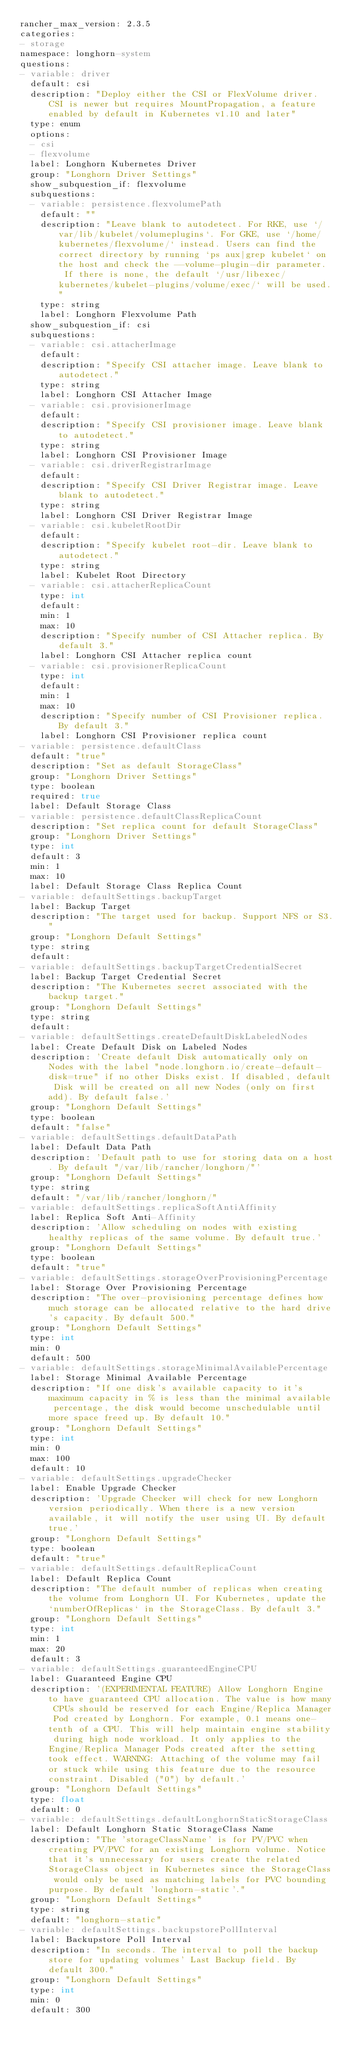<code> <loc_0><loc_0><loc_500><loc_500><_YAML_>rancher_max_version: 2.3.5
categories:
- storage
namespace: longhorn-system
questions:
- variable: driver
  default: csi
  description: "Deploy either the CSI or FlexVolume driver. CSI is newer but requires MountPropagation, a feature enabled by default in Kubernetes v1.10 and later"
  type: enum
  options:
  - csi
  - flexvolume
  label: Longhorn Kubernetes Driver
  group: "Longhorn Driver Settings"
  show_subquestion_if: flexvolume
  subquestions:
  - variable: persistence.flexvolumePath
    default: ""
    description: "Leave blank to autodetect. For RKE, use `/var/lib/kubelet/volumeplugins`. For GKE, use `/home/kubernetes/flexvolume/` instead. Users can find the correct directory by running `ps aux|grep kubelet` on the host and check the --volume-plugin-dir parameter.  If there is none, the default `/usr/libexec/kubernetes/kubelet-plugins/volume/exec/` will be used."
    type: string
    label: Longhorn Flexvolume Path
  show_subquestion_if: csi
  subquestions:
  - variable: csi.attacherImage
    default:
    description: "Specify CSI attacher image. Leave blank to autodetect."
    type: string
    label: Longhorn CSI Attacher Image
  - variable: csi.provisionerImage
    default:
    description: "Specify CSI provisioner image. Leave blank to autodetect."
    type: string
    label: Longhorn CSI Provisioner Image
  - variable: csi.driverRegistrarImage
    default:
    description: "Specify CSI Driver Registrar image. Leave blank to autodetect."
    type: string
    label: Longhorn CSI Driver Registrar Image
  - variable: csi.kubeletRootDir
    default:
    description: "Specify kubelet root-dir. Leave blank to autodetect."
    type: string
    label: Kubelet Root Directory
  - variable: csi.attacherReplicaCount
    type: int
    default:
    min: 1
    max: 10
    description: "Specify number of CSI Attacher replica. By default 3."
    label: Longhorn CSI Attacher replica count
  - variable: csi.provisionerReplicaCount
    type: int
    default:
    min: 1
    max: 10
    description: "Specify number of CSI Provisioner replica. By default 3."
    label: Longhorn CSI Provisioner replica count
- variable: persistence.defaultClass
  default: "true"
  description: "Set as default StorageClass"
  group: "Longhorn Driver Settings"
  type: boolean
  required: true
  label: Default Storage Class
- variable: persistence.defaultClassReplicaCount
  description: "Set replica count for default StorageClass"
  group: "Longhorn Driver Settings"
  type: int
  default: 3
  min: 1
  max: 10
  label: Default Storage Class Replica Count
- variable: defaultSettings.backupTarget
  label: Backup Target
  description: "The target used for backup. Support NFS or S3."
  group: "Longhorn Default Settings"
  type: string
  default:
- variable: defaultSettings.backupTargetCredentialSecret
  label: Backup Target Credential Secret
  description: "The Kubernetes secret associated with the backup target."
  group: "Longhorn Default Settings"
  type: string
  default:
- variable: defaultSettings.createDefaultDiskLabeledNodes
  label: Create Default Disk on Labeled Nodes
  description: 'Create default Disk automatically only on Nodes with the label "node.longhorn.io/create-default-disk=true" if no other Disks exist. If disabled, default Disk will be created on all new Nodes (only on first add). By default false.'
  group: "Longhorn Default Settings"
  type: boolean
  default: "false"
- variable: defaultSettings.defaultDataPath
  label: Default Data Path
  description: 'Default path to use for storing data on a host. By default "/var/lib/rancher/longhorn/"'
  group: "Longhorn Default Settings"
  type: string
  default: "/var/lib/rancher/longhorn/"
- variable: defaultSettings.replicaSoftAntiAffinity
  label: Replica Soft Anti-Affinity
  description: 'Allow scheduling on nodes with existing healthy replicas of the same volume. By default true.'
  group: "Longhorn Default Settings"
  type: boolean
  default: "true"
- variable: defaultSettings.storageOverProvisioningPercentage
  label: Storage Over Provisioning Percentage
  description: "The over-provisioning percentage defines how much storage can be allocated relative to the hard drive's capacity. By default 500."
  group: "Longhorn Default Settings"
  type: int
  min: 0
  default: 500
- variable: defaultSettings.storageMinimalAvailablePercentage
  label: Storage Minimal Available Percentage
  description: "If one disk's available capacity to it's maximum capacity in % is less than the minimal available percentage, the disk would become unschedulable until more space freed up. By default 10."
  group: "Longhorn Default Settings"
  type: int
  min: 0
  max: 100
  default: 10
- variable: defaultSettings.upgradeChecker
  label: Enable Upgrade Checker
  description: 'Upgrade Checker will check for new Longhorn version periodically. When there is a new version available, it will notify the user using UI. By default true.'
  group: "Longhorn Default Settings"
  type: boolean
  default: "true"
- variable: defaultSettings.defaultReplicaCount
  label: Default Replica Count
  description: "The default number of replicas when creating the volume from Longhorn UI. For Kubernetes, update the `numberOfReplicas` in the StorageClass. By default 3."
  group: "Longhorn Default Settings"
  type: int
  min: 1
  max: 20
  default: 3
- variable: defaultSettings.guaranteedEngineCPU
  label: Guaranteed Engine CPU
  description: '(EXPERIMENTAL FEATURE) Allow Longhorn Engine to have guaranteed CPU allocation. The value is how many CPUs should be reserved for each Engine/Replica Manager Pod created by Longhorn. For example, 0.1 means one-tenth of a CPU. This will help maintain engine stability during high node workload. It only applies to the Engine/Replica Manager Pods created after the setting took effect. WARNING: Attaching of the volume may fail or stuck while using this feature due to the resource constraint. Disabled ("0") by default.'
  group: "Longhorn Default Settings"
  type: float
  default: 0
- variable: defaultSettings.defaultLonghornStaticStorageClass
  label: Default Longhorn Static StorageClass Name
  description: "The 'storageClassName' is for PV/PVC when creating PV/PVC for an existing Longhorn volume. Notice that it's unnecessary for users create the related StorageClass object in Kubernetes since the StorageClass would only be used as matching labels for PVC bounding purpose. By default 'longhorn-static'."
  group: "Longhorn Default Settings"
  type: string
  default: "longhorn-static"
- variable: defaultSettings.backupstorePollInterval
  label: Backupstore Poll Interval
  description: "In seconds. The interval to poll the backup store for updating volumes' Last Backup field. By default 300."
  group: "Longhorn Default Settings"
  type: int
  min: 0
  default: 300</code> 